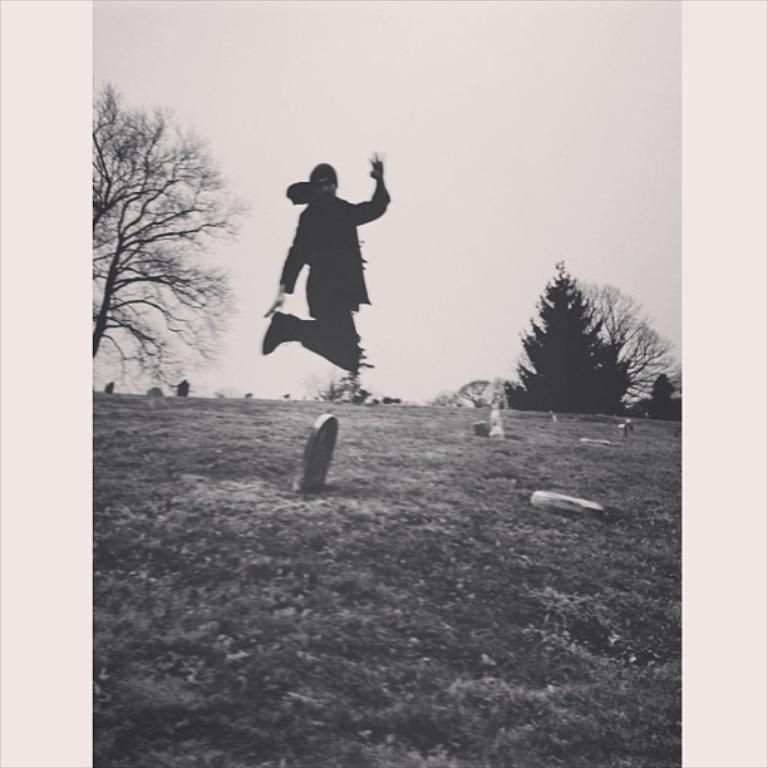What is the color scheme of the image? The image is black and white. What is the main subject of the image? There is a person in the image. What is the person doing in the image? The person is jumping. What can be seen on the path in the image? There are items on the path in the image. What is visible in the background of the image? There are trees and the sky visible in the background of the image. What type of error can be seen in the image? There is no error present in the image. Can you tell me how many monkeys are visible in the image? There are no monkeys present in the image. 